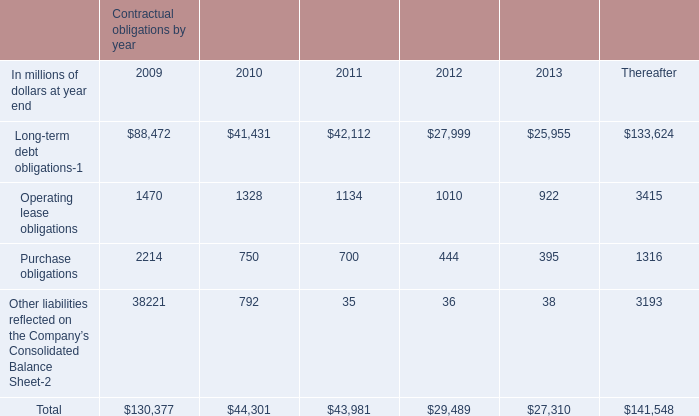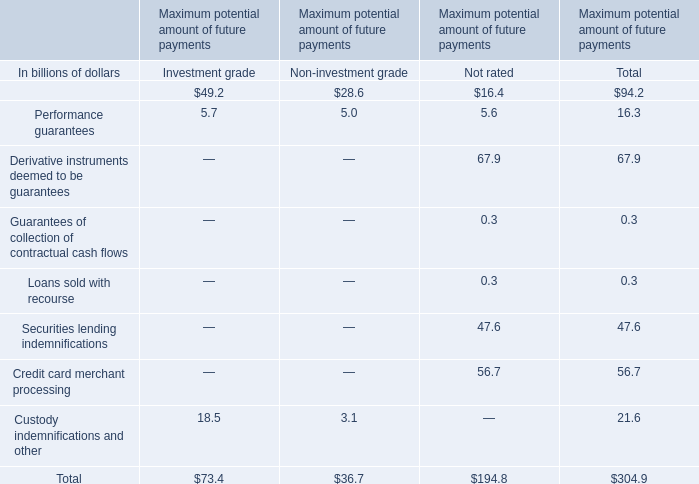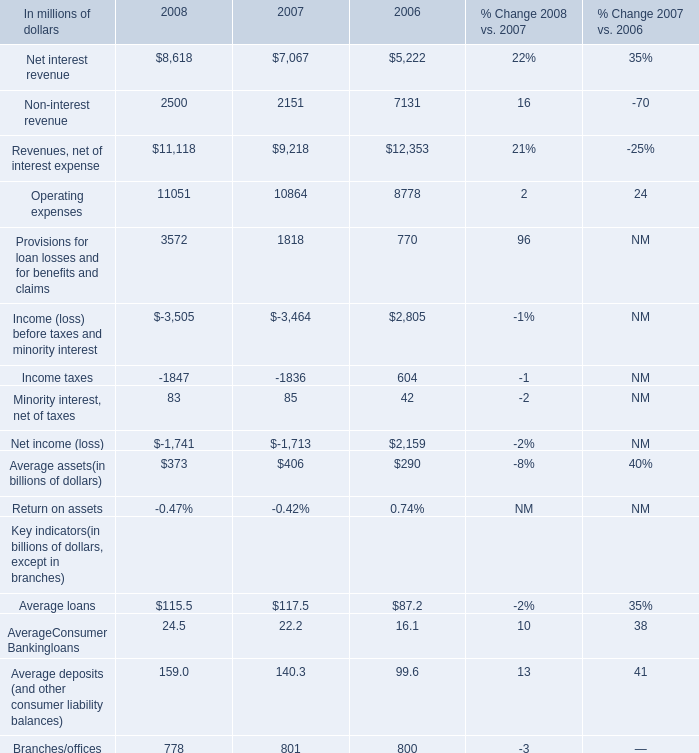What's the average of Purchase obligations of Contractual obligations by year 2009, and Operating expenses of 2008 ? 
Computations: ((2214.0 + 11051.0) / 2)
Answer: 6632.5. 